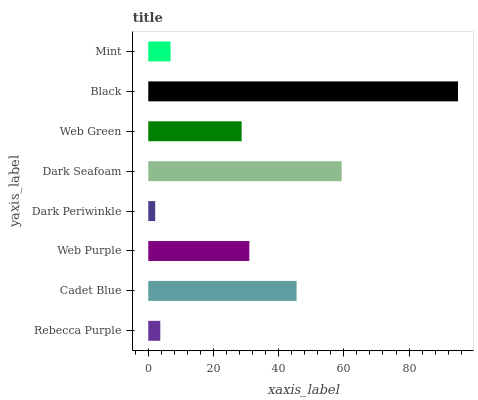Is Dark Periwinkle the minimum?
Answer yes or no. Yes. Is Black the maximum?
Answer yes or no. Yes. Is Cadet Blue the minimum?
Answer yes or no. No. Is Cadet Blue the maximum?
Answer yes or no. No. Is Cadet Blue greater than Rebecca Purple?
Answer yes or no. Yes. Is Rebecca Purple less than Cadet Blue?
Answer yes or no. Yes. Is Rebecca Purple greater than Cadet Blue?
Answer yes or no. No. Is Cadet Blue less than Rebecca Purple?
Answer yes or no. No. Is Web Purple the high median?
Answer yes or no. Yes. Is Web Green the low median?
Answer yes or no. Yes. Is Rebecca Purple the high median?
Answer yes or no. No. Is Black the low median?
Answer yes or no. No. 